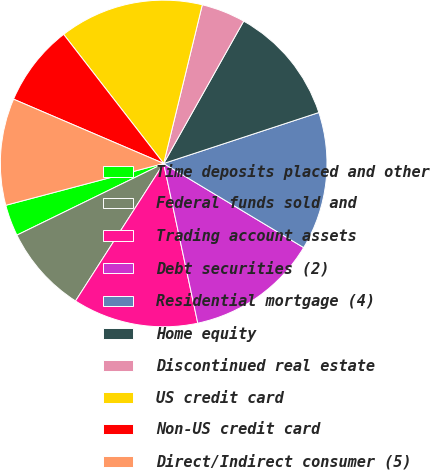Convert chart. <chart><loc_0><loc_0><loc_500><loc_500><pie_chart><fcel>Time deposits placed and other<fcel>Federal funds sold and<fcel>Trading account assets<fcel>Debt securities (2)<fcel>Residential mortgage (4)<fcel>Home equity<fcel>Discontinued real estate<fcel>US credit card<fcel>Non-US credit card<fcel>Direct/Indirect consumer (5)<nl><fcel>3.11%<fcel>8.7%<fcel>12.42%<fcel>13.04%<fcel>13.66%<fcel>11.8%<fcel>4.35%<fcel>14.29%<fcel>8.07%<fcel>10.56%<nl></chart> 